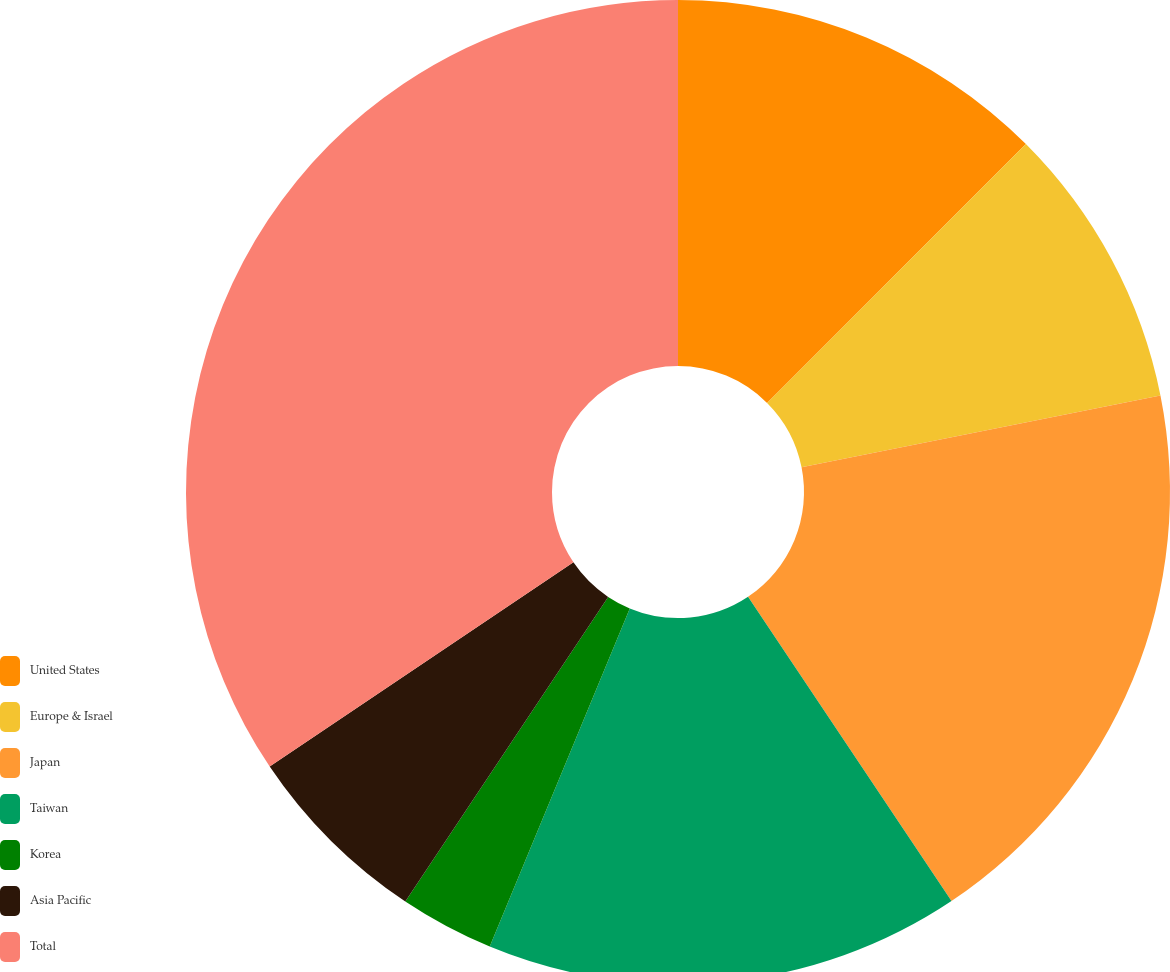<chart> <loc_0><loc_0><loc_500><loc_500><pie_chart><fcel>United States<fcel>Europe & Israel<fcel>Japan<fcel>Taiwan<fcel>Korea<fcel>Asia Pacific<fcel>Total<nl><fcel>12.5%<fcel>9.36%<fcel>18.76%<fcel>15.63%<fcel>3.1%<fcel>6.23%<fcel>34.42%<nl></chart> 